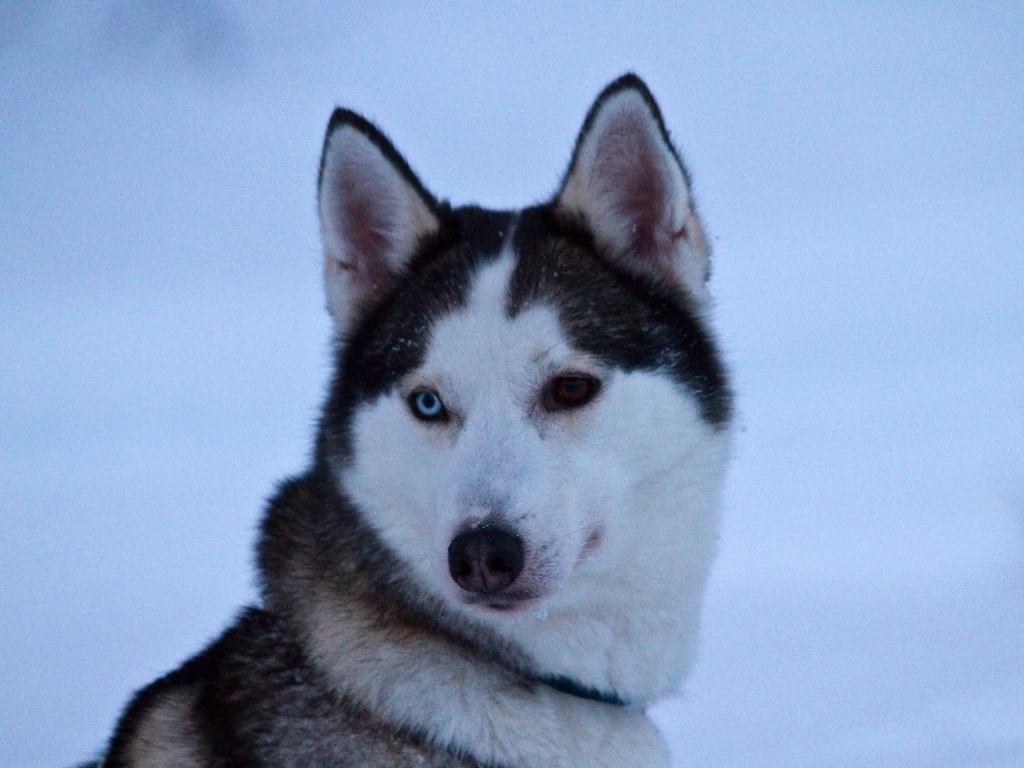What are the notable features of a Siberian Husky? Siberian Huskies are recognized for their dense double coat that provides insulation in cold weather, striking eyes that can be blue, brown, or even one of each—known as heterochromia. They also have a unique pattern of fur that often includes a mix of grey, black, and white, giving them a wolf-like appearance.  Could you tell me more about the Siberian Husky's temperament? Absolutely. Siberian Huskies are known for their energetic and playful nature. They are friendly and sociable, both with humans and other dogs. They have a strong pack instinct, are known to howl rather than bark, and would generally rather play than show any sort of aggression. 